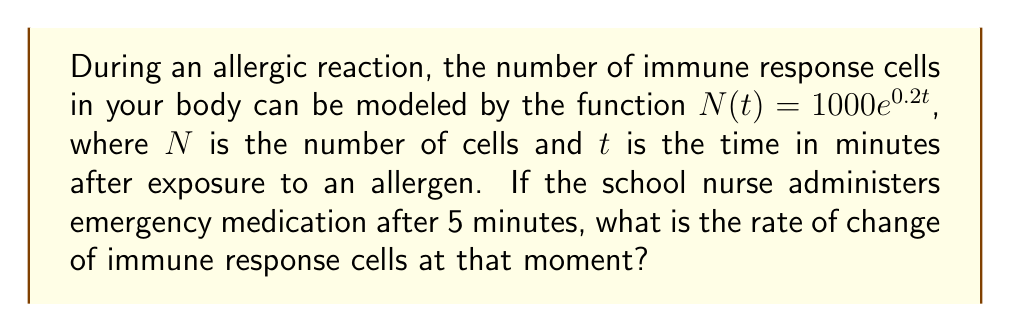Give your solution to this math problem. To solve this problem, we need to follow these steps:

1) The rate of change of the immune response cells is given by the derivative of the function $N(t)$.

2) To find the derivative, we use the rule for exponential functions:
   If $f(x) = e^{kx}$, then $f'(x) = ke^{kx}$

3) In our case, $N(t) = 1000e^{0.2t}$, so we can rewrite it as:
   $N(t) = 1000 \cdot e^{0.2t}$

4) Applying the derivative rule:
   $N'(t) = 1000 \cdot 0.2 \cdot e^{0.2t} = 200e^{0.2t}$

5) This gives us the rate of change at any time $t$. To find the rate at 5 minutes, we substitute $t=5$:
   $N'(5) = 200e^{0.2 \cdot 5} = 200e^1 \approx 543.8$

6) Therefore, at 5 minutes, the rate of change is approximately 543.8 cells per minute.
Answer: $N'(5) = 200e^1 \approx 543.8$ cells/minute 